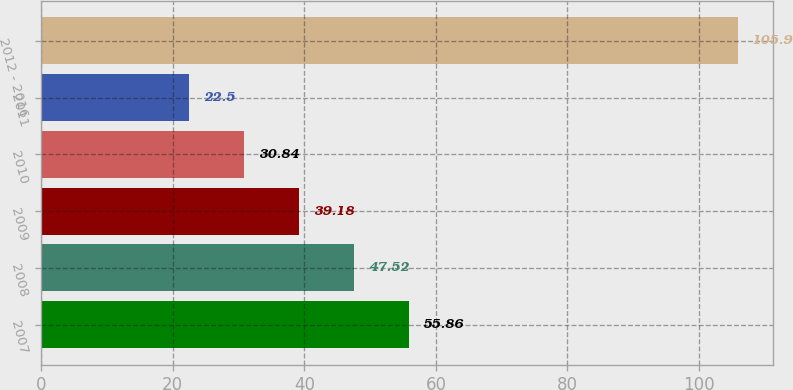<chart> <loc_0><loc_0><loc_500><loc_500><bar_chart><fcel>2007<fcel>2008<fcel>2009<fcel>2010<fcel>2011<fcel>2012 - 2016<nl><fcel>55.86<fcel>47.52<fcel>39.18<fcel>30.84<fcel>22.5<fcel>105.9<nl></chart> 